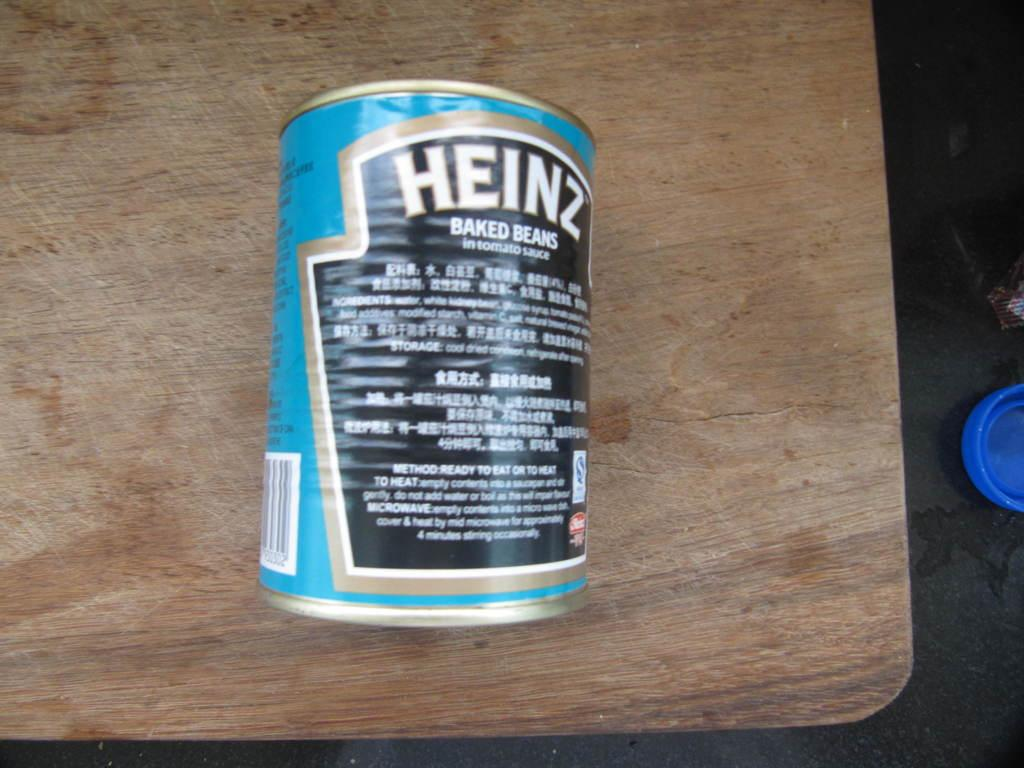What is the main object in the image? There is a food can in the image. Where is the food can located? The food can is placed on a wooden surface. Is there a notebook covering the food can in the image? No, there is no notebook present in the image. 